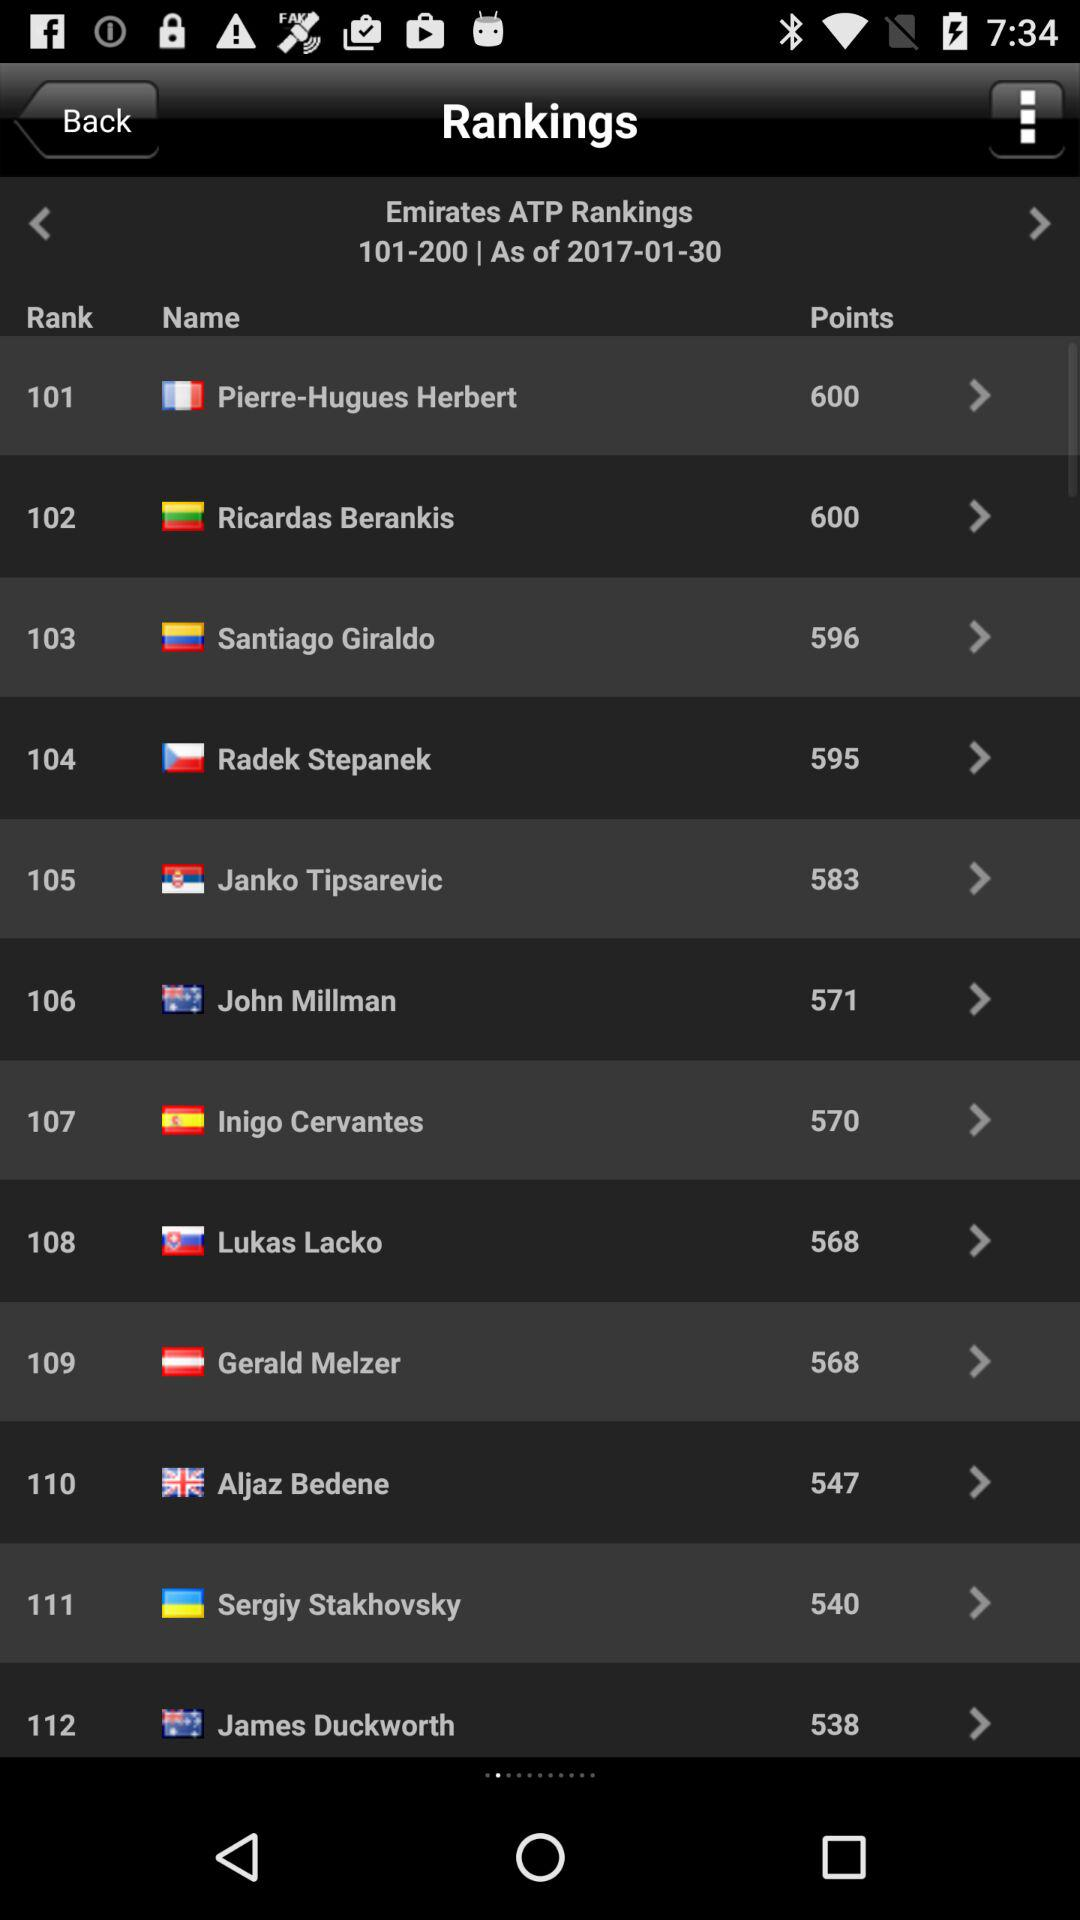Which player got 540 points? The player who got 540 points is Sergiy Stakhovsky. 